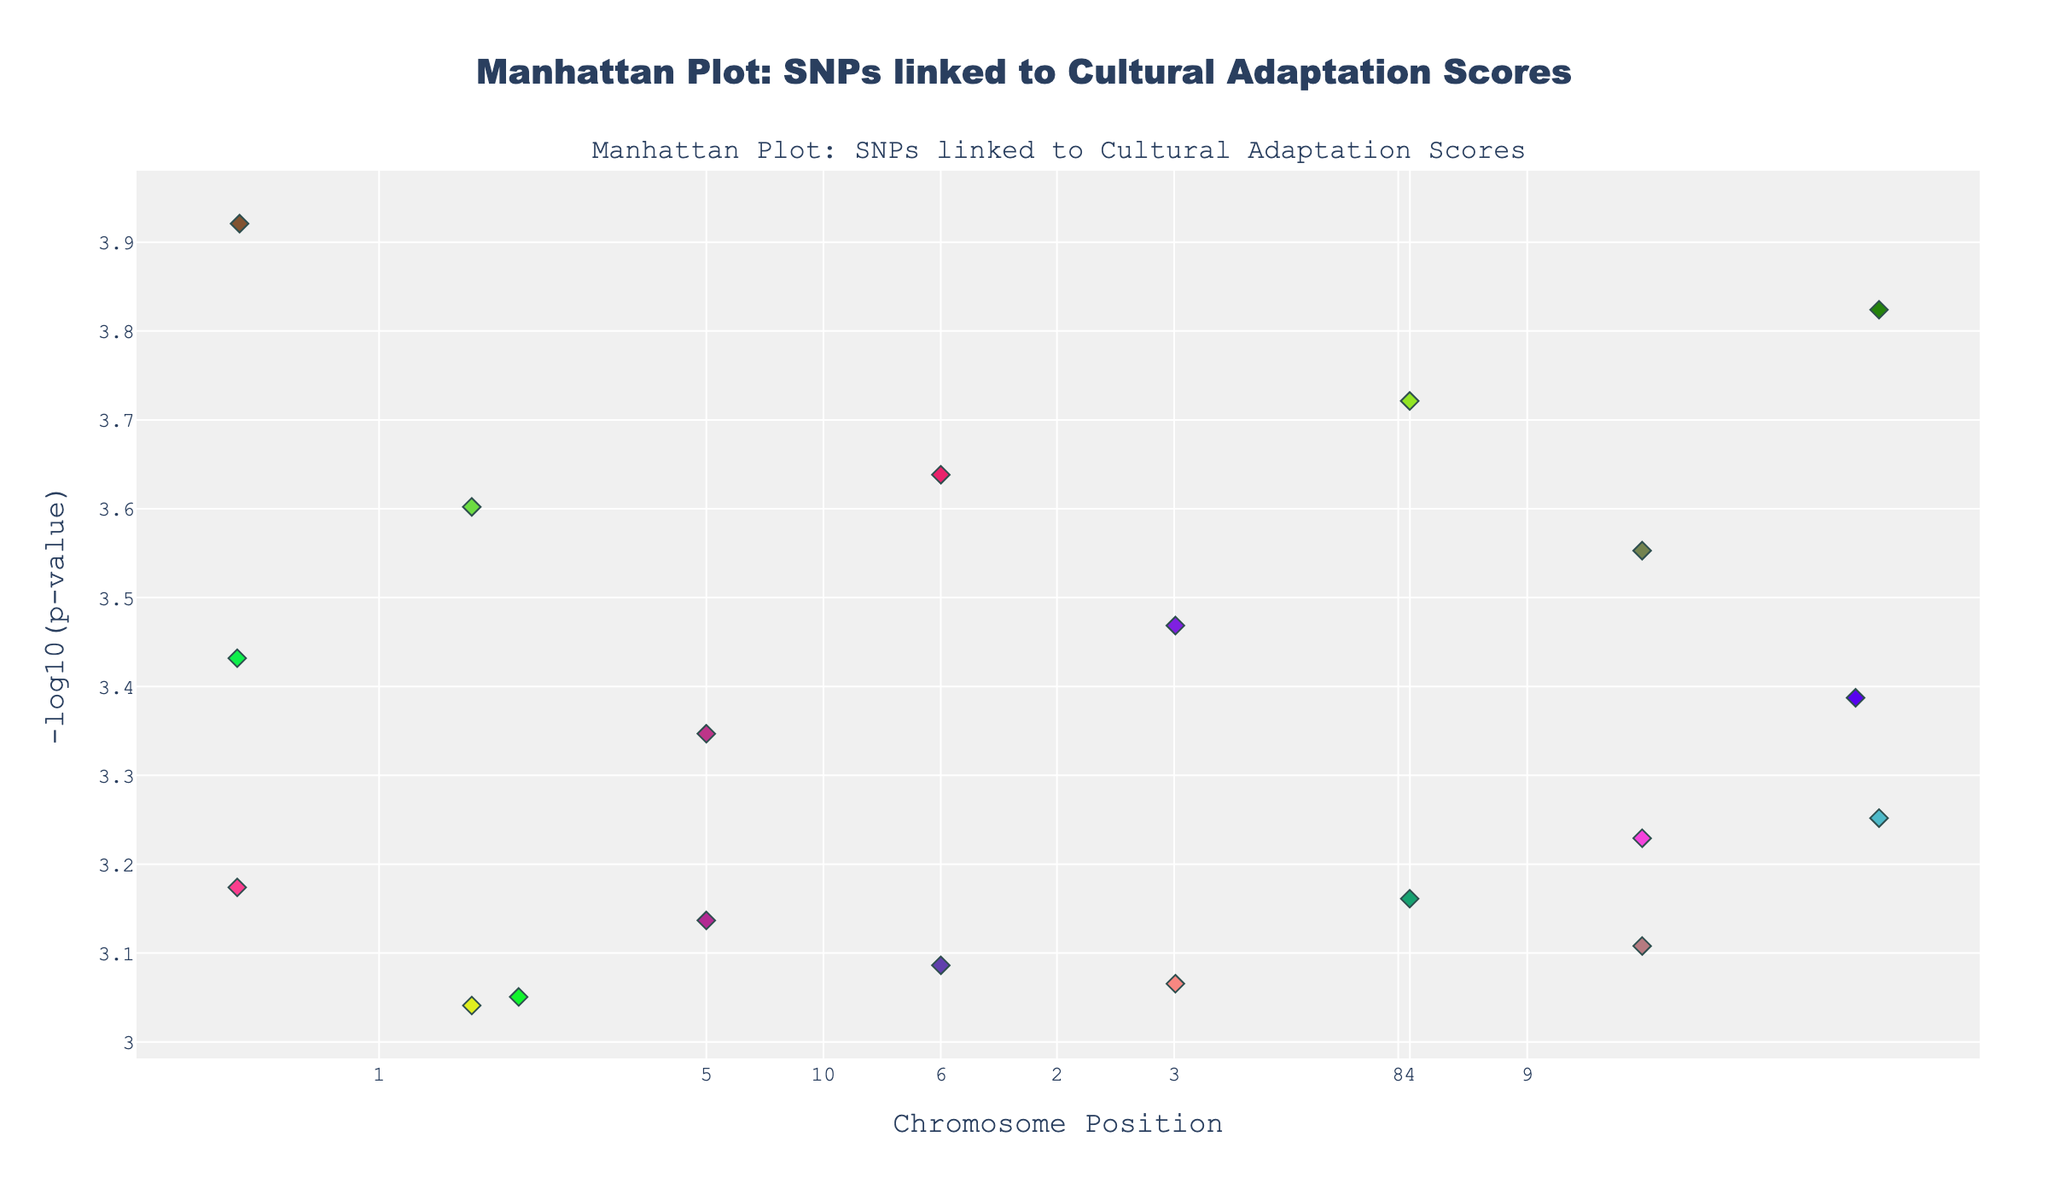What is the title of the plot? The title is at the top center of the plot and indicates what the visual represents. According to the figure information, the title is "Manhattan Plot: SNPs linked to Cultural Adaptation Scores".
Answer: Manhattan Plot: SNPs linked to Cultural Adaptation Scores Which chromosome has the SNP with the lowest P-value? First, identify the SNP with the lowest P-value by looking for the highest point on the y-axis (since it’s -log10 of P-value, higher points mean smaller P-values). The highest point corresponds to Paris (SNP rs2070424) on Chromosome 1.
Answer: Chromosome 1 How many different French cities are represented in the plot? To find the number of cities, count the unique entries in the legend that shows the color associated with each city. The data lists each city uniquely, thus simply counting the unique city colors would yield the total number of cities.
Answer: 20 Which city is represented by the color with the RGB value closest to a shade of blue on the plot? Locate the city associated with a color close to blue. By looking at the city legend and identifying shades that visually approximate blue, you determine the city with the closest blue shade from the city-to-color mapping provided in the code data. However, without seeing the exact plot, this question might rely on interpretation.
Answer: Unknown without visual interpretation How do the SNPs on Chromosome 5 compare to those on Chromosome 6 in terms of their P-values? Evaluate and compare the positions of points for Chromosomes 5 and 6 on the y-axis (as y-axis represents -log10(P-value)). For SNPs on Chromosome 5, look for the P-values (lower on the y-axis means higher P-values). Do the same for Chromosome 6, then determine the trend. In this case, SNPs on Chromosome 5 (e.g., rs9939609) tend to have lower P-values (higher on y-axis) compared to Chromosome 6.
Answer: Chromosome 5 SNPs generally have lower P-values Which chromosome shows the most diverse range of SNPs in terms of P-value? To evaluate diversity in P-values, examine which chromosome has the most spread on the y-axis. Chromosome 1, for example, has the top SNP rs2070424 with a very low P-value (high on y-axis), indicating a wide range in P-values among its SNPs.
Answer: Chromosome 1 What is the range of the -log10(P-value) for SNPs in Lyon? Identify SNPs from Lyon (from the color legend). Look at their positions on the y-axis and measure the range from the highest to the lowest y-value for these SNPs. For Lyon, the SNP rs4988235 has a P-value yielding a -log10(P-value) ~ 3.05. Compare it with the minimal -log10(P-value) value for Lyon SNPs.
Answer: About 3.05 to 3.05 (since Lyon has only one point) 